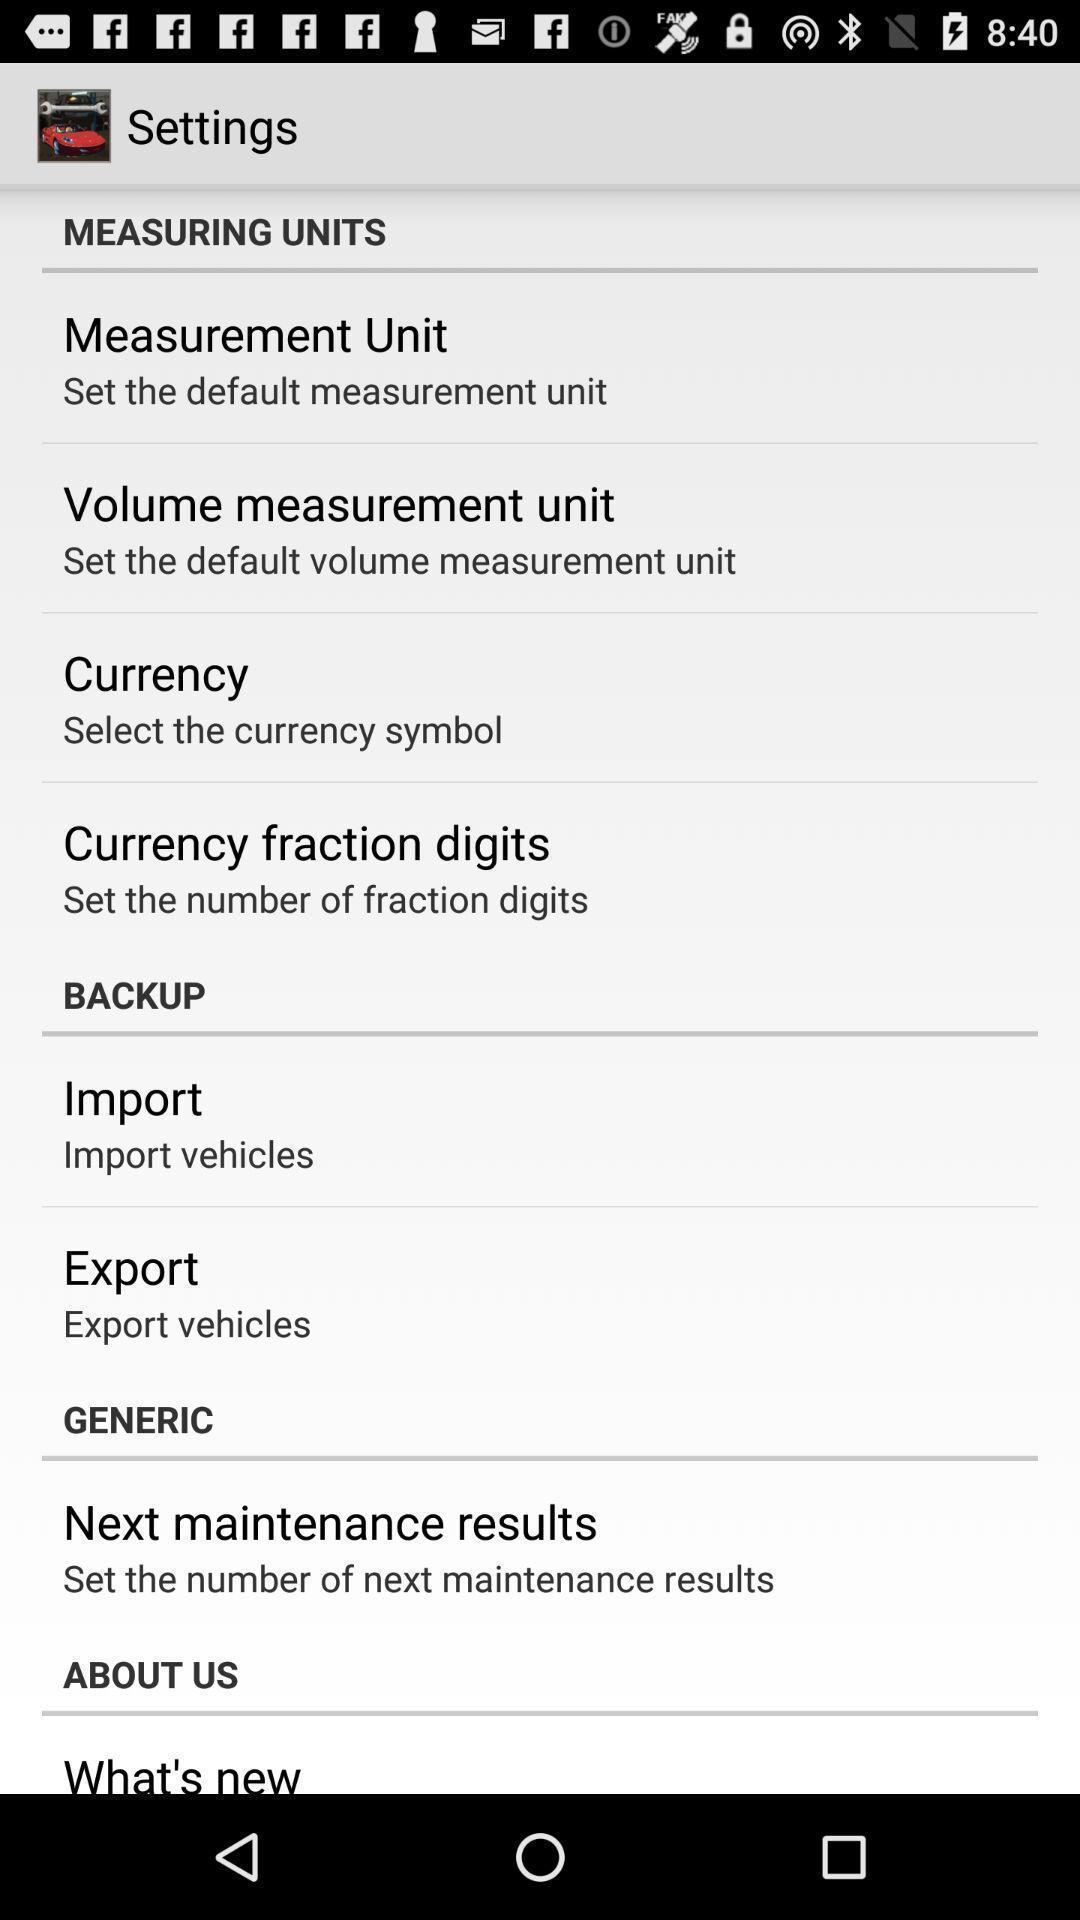Provide a textual representation of this image. Settings page with various other options. 